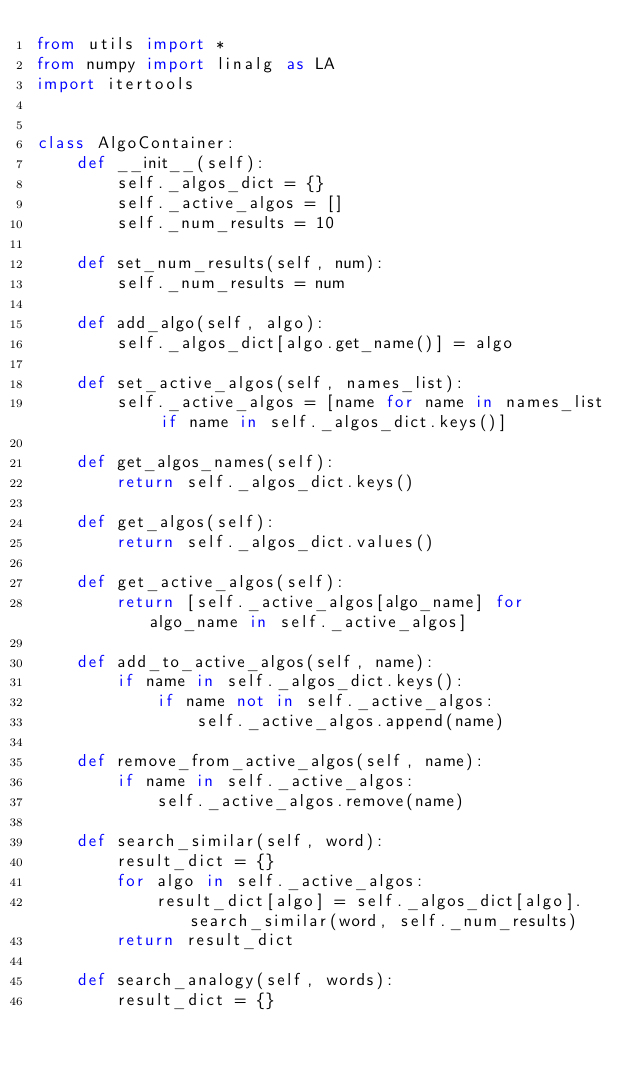<code> <loc_0><loc_0><loc_500><loc_500><_Python_>from utils import *
from numpy import linalg as LA
import itertools


class AlgoContainer:
    def __init__(self):
        self._algos_dict = {}
        self._active_algos = []
        self._num_results = 10

    def set_num_results(self, num):
        self._num_results = num

    def add_algo(self, algo):
        self._algos_dict[algo.get_name()] = algo

    def set_active_algos(self, names_list):
        self._active_algos = [name for name in names_list if name in self._algos_dict.keys()]

    def get_algos_names(self):
        return self._algos_dict.keys()

    def get_algos(self):
        return self._algos_dict.values()

    def get_active_algos(self):
        return [self._active_algos[algo_name] for algo_name in self._active_algos]

    def add_to_active_algos(self, name):
        if name in self._algos_dict.keys():
            if name not in self._active_algos:
                self._active_algos.append(name)

    def remove_from_active_algos(self, name):
        if name in self._active_algos:
            self._active_algos.remove(name)

    def search_similar(self, word):
        result_dict = {}
        for algo in self._active_algos:
            result_dict[algo] = self._algos_dict[algo].search_similar(word, self._num_results)
        return result_dict

    def search_analogy(self, words):
        result_dict = {}</code> 